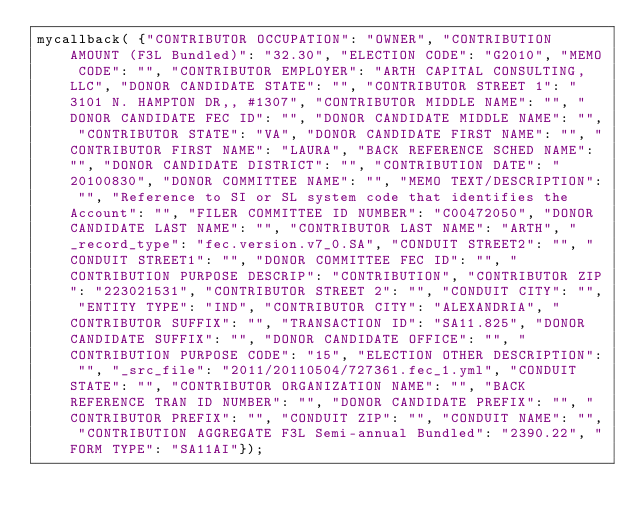<code> <loc_0><loc_0><loc_500><loc_500><_JavaScript_>mycallback( {"CONTRIBUTOR OCCUPATION": "OWNER", "CONTRIBUTION AMOUNT (F3L Bundled)": "32.30", "ELECTION CODE": "G2010", "MEMO CODE": "", "CONTRIBUTOR EMPLOYER": "ARTH CAPITAL CONSULTING, LLC", "DONOR CANDIDATE STATE": "", "CONTRIBUTOR STREET 1": "3101 N. HAMPTON DR,, #1307", "CONTRIBUTOR MIDDLE NAME": "", "DONOR CANDIDATE FEC ID": "", "DONOR CANDIDATE MIDDLE NAME": "", "CONTRIBUTOR STATE": "VA", "DONOR CANDIDATE FIRST NAME": "", "CONTRIBUTOR FIRST NAME": "LAURA", "BACK REFERENCE SCHED NAME": "", "DONOR CANDIDATE DISTRICT": "", "CONTRIBUTION DATE": "20100830", "DONOR COMMITTEE NAME": "", "MEMO TEXT/DESCRIPTION": "", "Reference to SI or SL system code that identifies the Account": "", "FILER COMMITTEE ID NUMBER": "C00472050", "DONOR CANDIDATE LAST NAME": "", "CONTRIBUTOR LAST NAME": "ARTH", "_record_type": "fec.version.v7_0.SA", "CONDUIT STREET2": "", "CONDUIT STREET1": "", "DONOR COMMITTEE FEC ID": "", "CONTRIBUTION PURPOSE DESCRIP": "CONTRIBUTION", "CONTRIBUTOR ZIP": "223021531", "CONTRIBUTOR STREET 2": "", "CONDUIT CITY": "", "ENTITY TYPE": "IND", "CONTRIBUTOR CITY": "ALEXANDRIA", "CONTRIBUTOR SUFFIX": "", "TRANSACTION ID": "SA11.825", "DONOR CANDIDATE SUFFIX": "", "DONOR CANDIDATE OFFICE": "", "CONTRIBUTION PURPOSE CODE": "15", "ELECTION OTHER DESCRIPTION": "", "_src_file": "2011/20110504/727361.fec_1.yml", "CONDUIT STATE": "", "CONTRIBUTOR ORGANIZATION NAME": "", "BACK REFERENCE TRAN ID NUMBER": "", "DONOR CANDIDATE PREFIX": "", "CONTRIBUTOR PREFIX": "", "CONDUIT ZIP": "", "CONDUIT NAME": "", "CONTRIBUTION AGGREGATE F3L Semi-annual Bundled": "2390.22", "FORM TYPE": "SA11AI"});</code> 